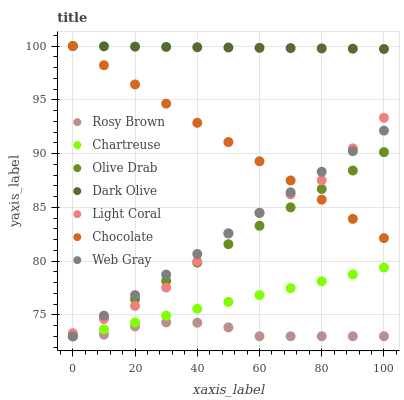Does Rosy Brown have the minimum area under the curve?
Answer yes or no. Yes. Does Dark Olive have the maximum area under the curve?
Answer yes or no. Yes. Does Chocolate have the minimum area under the curve?
Answer yes or no. No. Does Chocolate have the maximum area under the curve?
Answer yes or no. No. Is Chartreuse the smoothest?
Answer yes or no. Yes. Is Light Coral the roughest?
Answer yes or no. Yes. Is Dark Olive the smoothest?
Answer yes or no. No. Is Dark Olive the roughest?
Answer yes or no. No. Does Rosy Brown have the lowest value?
Answer yes or no. Yes. Does Chocolate have the lowest value?
Answer yes or no. No. Does Chocolate have the highest value?
Answer yes or no. Yes. Does Light Coral have the highest value?
Answer yes or no. No. Is Chartreuse less than Light Coral?
Answer yes or no. Yes. Is Dark Olive greater than Chartreuse?
Answer yes or no. Yes. Does Web Gray intersect Olive Drab?
Answer yes or no. Yes. Is Web Gray less than Olive Drab?
Answer yes or no. No. Is Web Gray greater than Olive Drab?
Answer yes or no. No. Does Chartreuse intersect Light Coral?
Answer yes or no. No. 